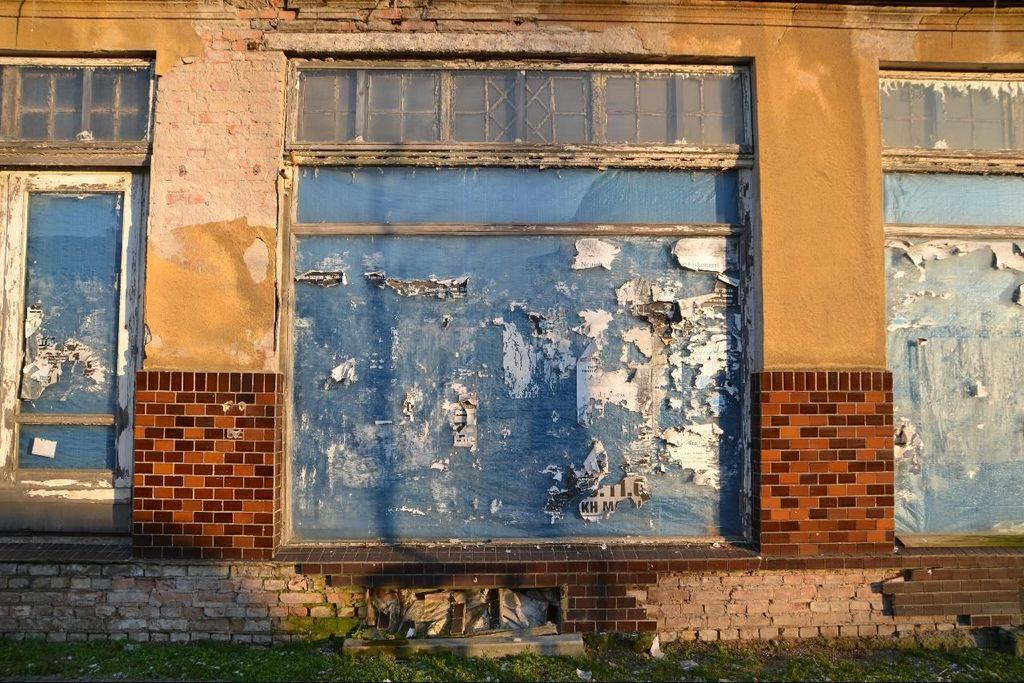What is a prominent feature of the image? There is a wall in the image. What is special about the wall? The wall has glass windows on it. What is placed on the windows? Papers are stuck on the windows. What can be seen at the bottom of the image? There is grass on the ground at the bottom of the image. What type of carriage is being used for the operation in the image? There is no carriage or operation present in the image; it features a wall with glass windows and papers stuck on them, as well as grass at the bottom. 